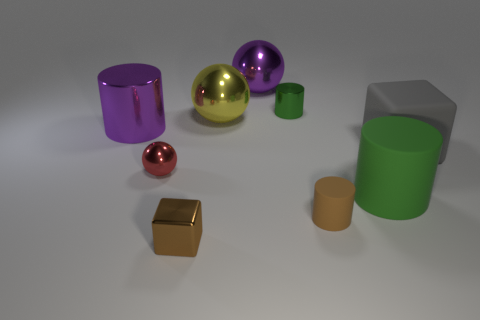What material is the large ball that is the same color as the large metal cylinder?
Make the answer very short. Metal. What number of other things are the same color as the tiny rubber thing?
Make the answer very short. 1. How many other things are there of the same material as the yellow sphere?
Your answer should be very brief. 5. What number of objects are green cylinders in front of the small green shiny object or big metal objects in front of the large yellow object?
Your answer should be very brief. 2. There is a yellow thing that is the same shape as the small red metallic object; what is it made of?
Your response must be concise. Metal. Is there a tiny cyan matte object?
Provide a succinct answer. No. How big is the thing that is both left of the small brown cylinder and on the right side of the purple shiny ball?
Your answer should be very brief. Small. What shape is the big gray matte thing?
Keep it short and to the point. Cube. There is a purple metal object to the right of the small metallic cube; are there any red balls that are behind it?
Your answer should be compact. No. What material is the green cylinder that is the same size as the brown cylinder?
Your answer should be very brief. Metal. 